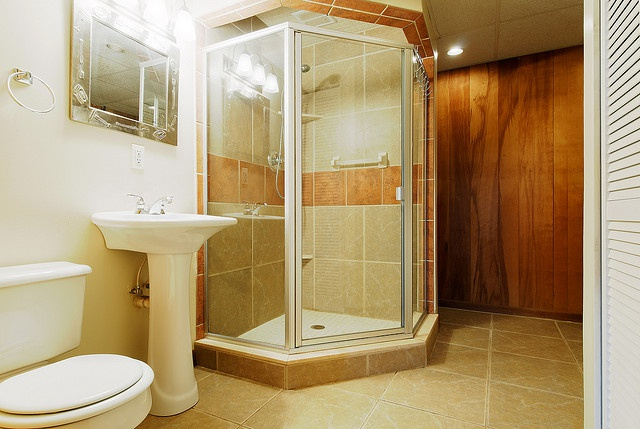Describe the objects in this image and their specific colors. I can see toilet in lightgray and tan tones and sink in lightgray, white, darkgray, and tan tones in this image. 